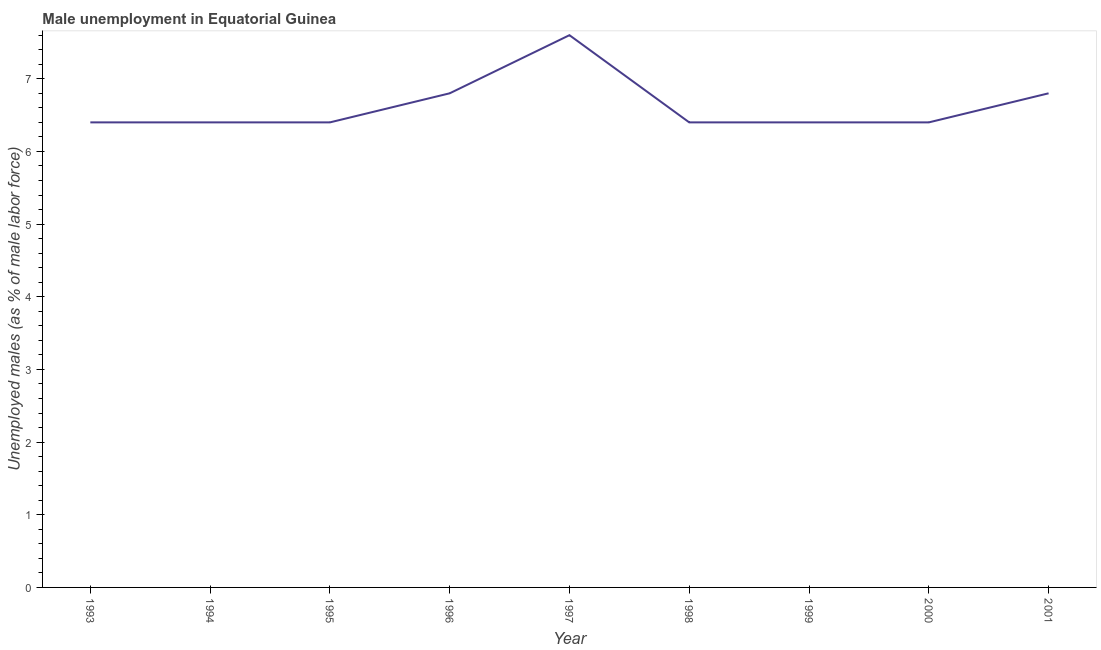What is the unemployed males population in 1999?
Your answer should be very brief. 6.4. Across all years, what is the maximum unemployed males population?
Make the answer very short. 7.6. Across all years, what is the minimum unemployed males population?
Make the answer very short. 6.4. In which year was the unemployed males population maximum?
Offer a terse response. 1997. What is the sum of the unemployed males population?
Your response must be concise. 59.6. What is the difference between the unemployed males population in 1995 and 1996?
Provide a succinct answer. -0.4. What is the average unemployed males population per year?
Offer a very short reply. 6.62. What is the median unemployed males population?
Make the answer very short. 6.4. What is the ratio of the unemployed males population in 1997 to that in 2001?
Provide a short and direct response. 1.12. Is the unemployed males population in 1994 less than that in 2000?
Ensure brevity in your answer.  No. Is the difference between the unemployed males population in 1996 and 1998 greater than the difference between any two years?
Your response must be concise. No. What is the difference between the highest and the second highest unemployed males population?
Offer a terse response. 0.8. What is the difference between the highest and the lowest unemployed males population?
Give a very brief answer. 1.2. How many years are there in the graph?
Offer a very short reply. 9. What is the difference between two consecutive major ticks on the Y-axis?
Provide a short and direct response. 1. What is the title of the graph?
Your answer should be very brief. Male unemployment in Equatorial Guinea. What is the label or title of the X-axis?
Offer a very short reply. Year. What is the label or title of the Y-axis?
Your response must be concise. Unemployed males (as % of male labor force). What is the Unemployed males (as % of male labor force) of 1993?
Offer a very short reply. 6.4. What is the Unemployed males (as % of male labor force) in 1994?
Give a very brief answer. 6.4. What is the Unemployed males (as % of male labor force) of 1995?
Your answer should be very brief. 6.4. What is the Unemployed males (as % of male labor force) of 1996?
Make the answer very short. 6.8. What is the Unemployed males (as % of male labor force) in 1997?
Keep it short and to the point. 7.6. What is the Unemployed males (as % of male labor force) in 1998?
Keep it short and to the point. 6.4. What is the Unemployed males (as % of male labor force) of 1999?
Ensure brevity in your answer.  6.4. What is the Unemployed males (as % of male labor force) of 2000?
Offer a very short reply. 6.4. What is the Unemployed males (as % of male labor force) in 2001?
Provide a short and direct response. 6.8. What is the difference between the Unemployed males (as % of male labor force) in 1993 and 1994?
Your response must be concise. 0. What is the difference between the Unemployed males (as % of male labor force) in 1993 and 1995?
Offer a very short reply. 0. What is the difference between the Unemployed males (as % of male labor force) in 1993 and 2001?
Offer a terse response. -0.4. What is the difference between the Unemployed males (as % of male labor force) in 1994 and 1995?
Make the answer very short. 0. What is the difference between the Unemployed males (as % of male labor force) in 1994 and 1999?
Make the answer very short. 0. What is the difference between the Unemployed males (as % of male labor force) in 1994 and 2001?
Offer a very short reply. -0.4. What is the difference between the Unemployed males (as % of male labor force) in 1995 and 1997?
Keep it short and to the point. -1.2. What is the difference between the Unemployed males (as % of male labor force) in 1995 and 1999?
Ensure brevity in your answer.  0. What is the difference between the Unemployed males (as % of male labor force) in 1995 and 2000?
Your answer should be very brief. 0. What is the difference between the Unemployed males (as % of male labor force) in 1995 and 2001?
Keep it short and to the point. -0.4. What is the difference between the Unemployed males (as % of male labor force) in 1996 and 1998?
Provide a short and direct response. 0.4. What is the difference between the Unemployed males (as % of male labor force) in 1996 and 2000?
Your response must be concise. 0.4. What is the difference between the Unemployed males (as % of male labor force) in 1997 and 1998?
Provide a succinct answer. 1.2. What is the difference between the Unemployed males (as % of male labor force) in 1997 and 1999?
Offer a very short reply. 1.2. What is the difference between the Unemployed males (as % of male labor force) in 1998 and 1999?
Provide a short and direct response. 0. What is the difference between the Unemployed males (as % of male labor force) in 1998 and 2001?
Ensure brevity in your answer.  -0.4. What is the difference between the Unemployed males (as % of male labor force) in 2000 and 2001?
Offer a terse response. -0.4. What is the ratio of the Unemployed males (as % of male labor force) in 1993 to that in 1994?
Make the answer very short. 1. What is the ratio of the Unemployed males (as % of male labor force) in 1993 to that in 1996?
Keep it short and to the point. 0.94. What is the ratio of the Unemployed males (as % of male labor force) in 1993 to that in 1997?
Ensure brevity in your answer.  0.84. What is the ratio of the Unemployed males (as % of male labor force) in 1993 to that in 1998?
Give a very brief answer. 1. What is the ratio of the Unemployed males (as % of male labor force) in 1993 to that in 2000?
Provide a succinct answer. 1. What is the ratio of the Unemployed males (as % of male labor force) in 1993 to that in 2001?
Make the answer very short. 0.94. What is the ratio of the Unemployed males (as % of male labor force) in 1994 to that in 1996?
Your response must be concise. 0.94. What is the ratio of the Unemployed males (as % of male labor force) in 1994 to that in 1997?
Ensure brevity in your answer.  0.84. What is the ratio of the Unemployed males (as % of male labor force) in 1994 to that in 1998?
Your answer should be very brief. 1. What is the ratio of the Unemployed males (as % of male labor force) in 1994 to that in 1999?
Your response must be concise. 1. What is the ratio of the Unemployed males (as % of male labor force) in 1994 to that in 2000?
Make the answer very short. 1. What is the ratio of the Unemployed males (as % of male labor force) in 1994 to that in 2001?
Your answer should be compact. 0.94. What is the ratio of the Unemployed males (as % of male labor force) in 1995 to that in 1996?
Provide a short and direct response. 0.94. What is the ratio of the Unemployed males (as % of male labor force) in 1995 to that in 1997?
Ensure brevity in your answer.  0.84. What is the ratio of the Unemployed males (as % of male labor force) in 1995 to that in 1998?
Give a very brief answer. 1. What is the ratio of the Unemployed males (as % of male labor force) in 1995 to that in 2000?
Make the answer very short. 1. What is the ratio of the Unemployed males (as % of male labor force) in 1995 to that in 2001?
Offer a terse response. 0.94. What is the ratio of the Unemployed males (as % of male labor force) in 1996 to that in 1997?
Offer a very short reply. 0.9. What is the ratio of the Unemployed males (as % of male labor force) in 1996 to that in 1998?
Ensure brevity in your answer.  1.06. What is the ratio of the Unemployed males (as % of male labor force) in 1996 to that in 1999?
Provide a succinct answer. 1.06. What is the ratio of the Unemployed males (as % of male labor force) in 1996 to that in 2000?
Your answer should be very brief. 1.06. What is the ratio of the Unemployed males (as % of male labor force) in 1997 to that in 1998?
Offer a terse response. 1.19. What is the ratio of the Unemployed males (as % of male labor force) in 1997 to that in 1999?
Offer a terse response. 1.19. What is the ratio of the Unemployed males (as % of male labor force) in 1997 to that in 2000?
Provide a succinct answer. 1.19. What is the ratio of the Unemployed males (as % of male labor force) in 1997 to that in 2001?
Your response must be concise. 1.12. What is the ratio of the Unemployed males (as % of male labor force) in 1998 to that in 1999?
Provide a short and direct response. 1. What is the ratio of the Unemployed males (as % of male labor force) in 1998 to that in 2000?
Give a very brief answer. 1. What is the ratio of the Unemployed males (as % of male labor force) in 1998 to that in 2001?
Provide a short and direct response. 0.94. What is the ratio of the Unemployed males (as % of male labor force) in 1999 to that in 2000?
Your answer should be compact. 1. What is the ratio of the Unemployed males (as % of male labor force) in 1999 to that in 2001?
Make the answer very short. 0.94. What is the ratio of the Unemployed males (as % of male labor force) in 2000 to that in 2001?
Your answer should be very brief. 0.94. 